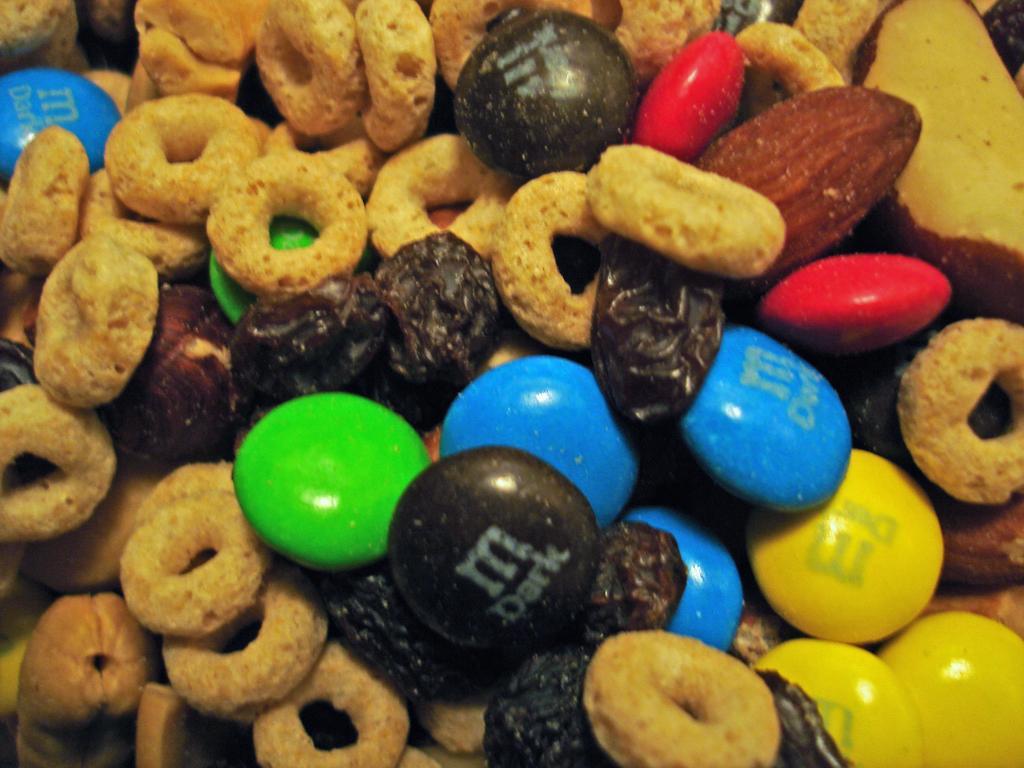Could you give a brief overview of what you see in this image? In this image we can see gems, apple and some other food items. 